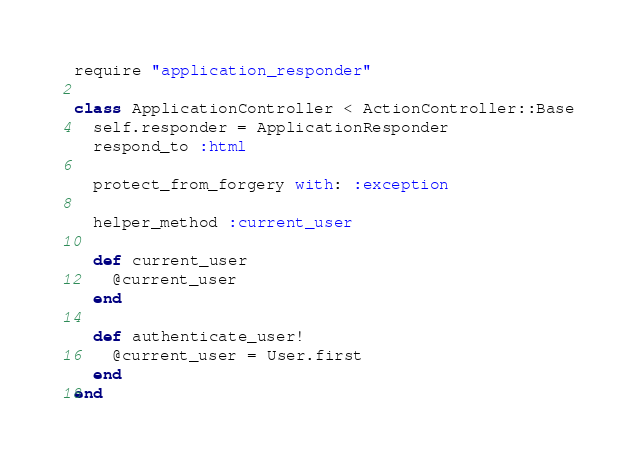Convert code to text. <code><loc_0><loc_0><loc_500><loc_500><_Ruby_>require "application_responder"

class ApplicationController < ActionController::Base
  self.responder = ApplicationResponder
  respond_to :html

  protect_from_forgery with: :exception

  helper_method :current_user

  def current_user
  	@current_user
  end

  def authenticate_user!
  	@current_user = User.first
  end
end
</code> 